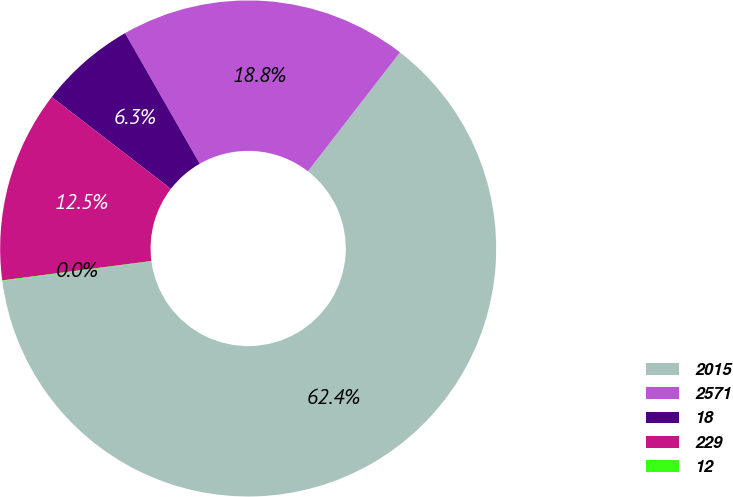Convert chart to OTSL. <chart><loc_0><loc_0><loc_500><loc_500><pie_chart><fcel>2015<fcel>2571<fcel>18<fcel>229<fcel>12<nl><fcel>62.42%<fcel>18.75%<fcel>6.28%<fcel>12.51%<fcel>0.04%<nl></chart> 